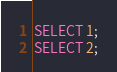<code> <loc_0><loc_0><loc_500><loc_500><_SQL_>SELECT 1;
SELECT 2;
</code> 